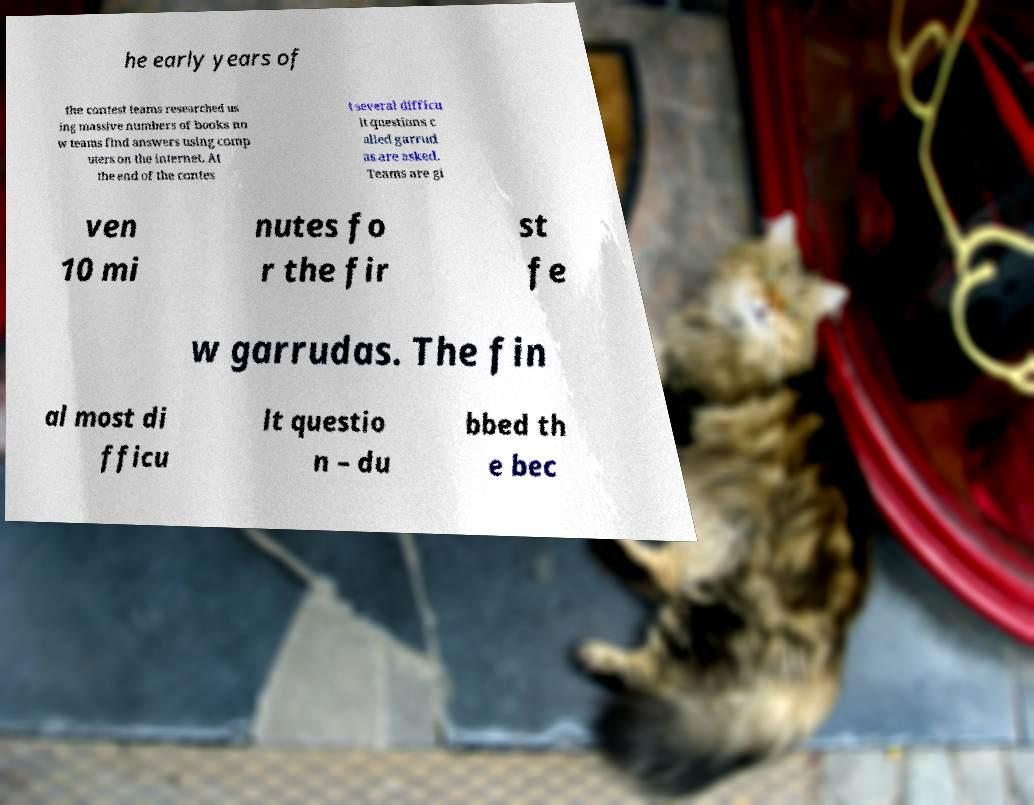Could you extract and type out the text from this image? he early years of the contest teams researched us ing massive numbers of books no w teams find answers using comp uters on the internet. At the end of the contes t several difficu lt questions c alled garrud as are asked. Teams are gi ven 10 mi nutes fo r the fir st fe w garrudas. The fin al most di fficu lt questio n – du bbed th e bec 